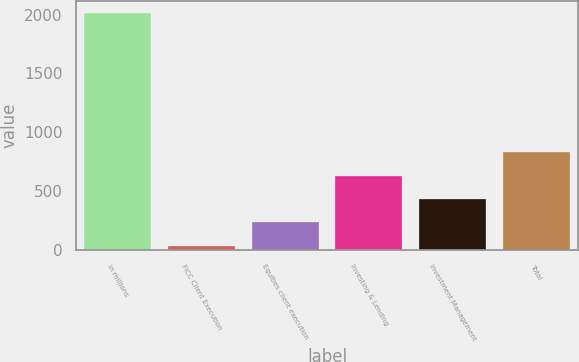<chart> <loc_0><loc_0><loc_500><loc_500><bar_chart><fcel>in millions<fcel>FICC Client Execution<fcel>Equities client execution<fcel>Investing & Lending<fcel>Investment Management<fcel>Total<nl><fcel>2017<fcel>37<fcel>235<fcel>631<fcel>433<fcel>829<nl></chart> 